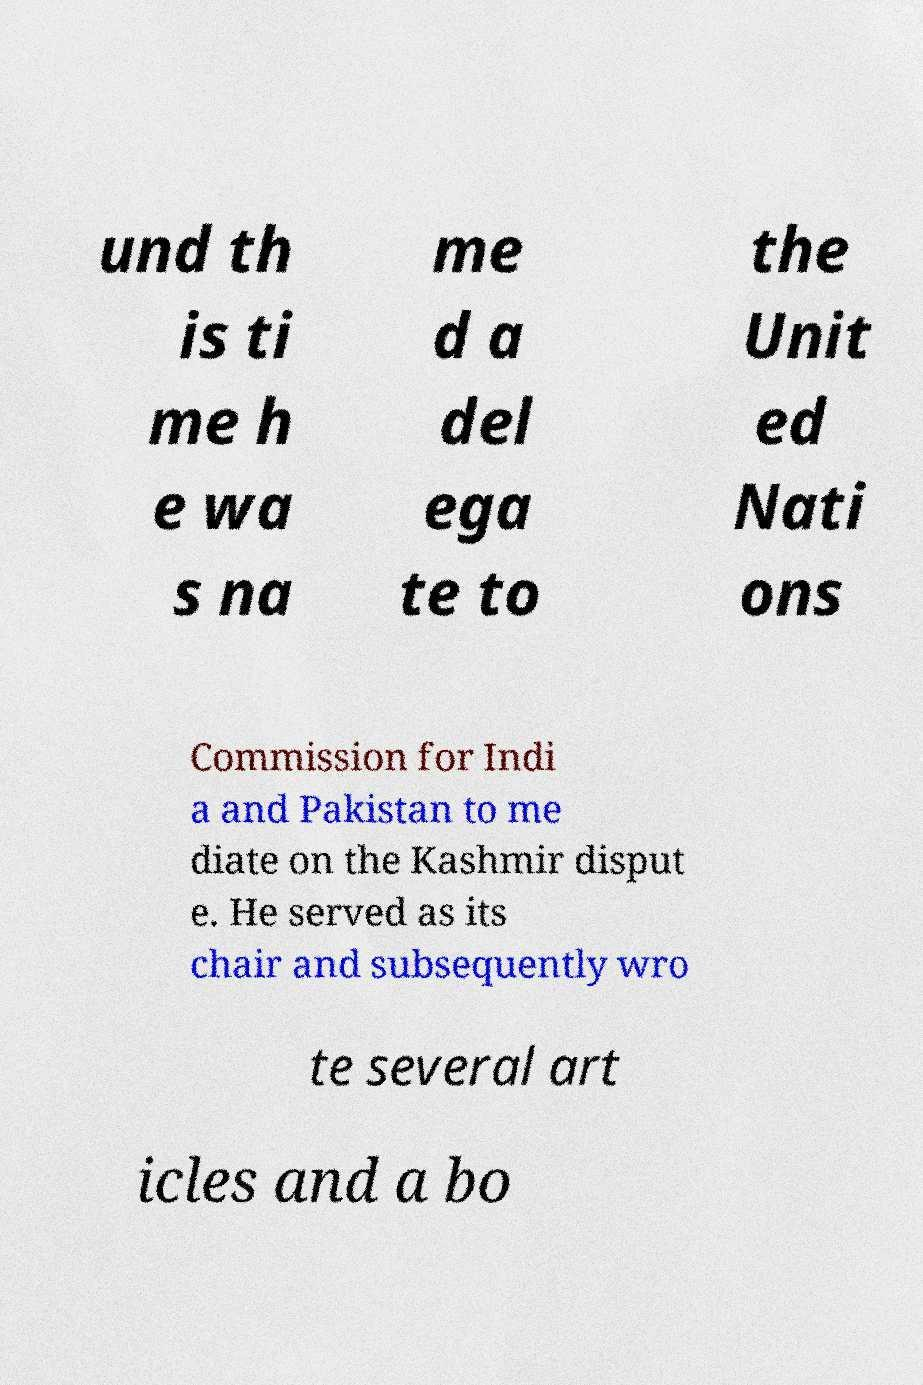I need the written content from this picture converted into text. Can you do that? und th is ti me h e wa s na me d a del ega te to the Unit ed Nati ons Commission for Indi a and Pakistan to me diate on the Kashmir disput e. He served as its chair and subsequently wro te several art icles and a bo 